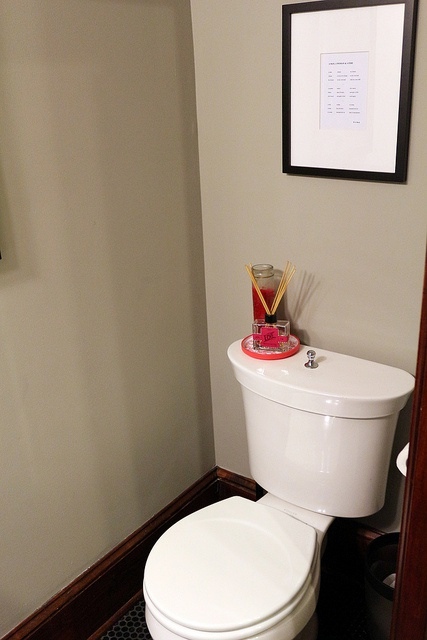Describe the objects in this image and their specific colors. I can see toilet in gray, lightgray, and darkgray tones, toilet in gray, white, darkgray, and black tones, bottle in tan, brown, and maroon tones, and bottle in tan, gray, and maroon tones in this image. 